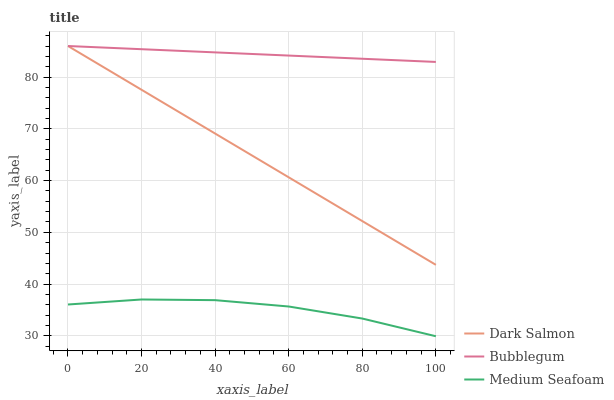Does Medium Seafoam have the minimum area under the curve?
Answer yes or no. Yes. Does Bubblegum have the maximum area under the curve?
Answer yes or no. Yes. Does Bubblegum have the minimum area under the curve?
Answer yes or no. No. Does Medium Seafoam have the maximum area under the curve?
Answer yes or no. No. Is Bubblegum the smoothest?
Answer yes or no. Yes. Is Medium Seafoam the roughest?
Answer yes or no. Yes. Is Medium Seafoam the smoothest?
Answer yes or no. No. Is Bubblegum the roughest?
Answer yes or no. No. Does Medium Seafoam have the lowest value?
Answer yes or no. Yes. Does Bubblegum have the lowest value?
Answer yes or no. No. Does Bubblegum have the highest value?
Answer yes or no. Yes. Does Medium Seafoam have the highest value?
Answer yes or no. No. Is Medium Seafoam less than Bubblegum?
Answer yes or no. Yes. Is Bubblegum greater than Medium Seafoam?
Answer yes or no. Yes. Does Dark Salmon intersect Bubblegum?
Answer yes or no. Yes. Is Dark Salmon less than Bubblegum?
Answer yes or no. No. Is Dark Salmon greater than Bubblegum?
Answer yes or no. No. Does Medium Seafoam intersect Bubblegum?
Answer yes or no. No. 